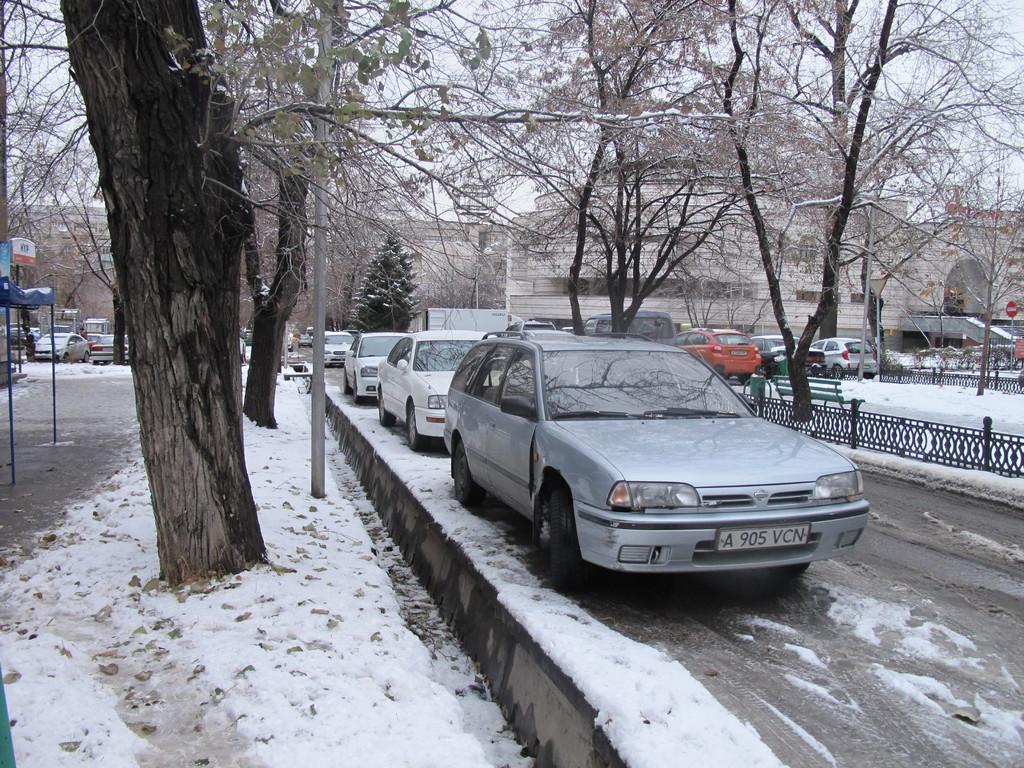Describe this image in one or two sentences. To the left side of the image there is a snow on the floor and also a tree. And to the left corner of the image there is a tent and vehicles. And to the right of the image there are few cars are on the road. Beside the cars there is a fencing. Behind the fencing there are trees, benches, vehicles and sign boards. And in the background there are buildings and trees. 